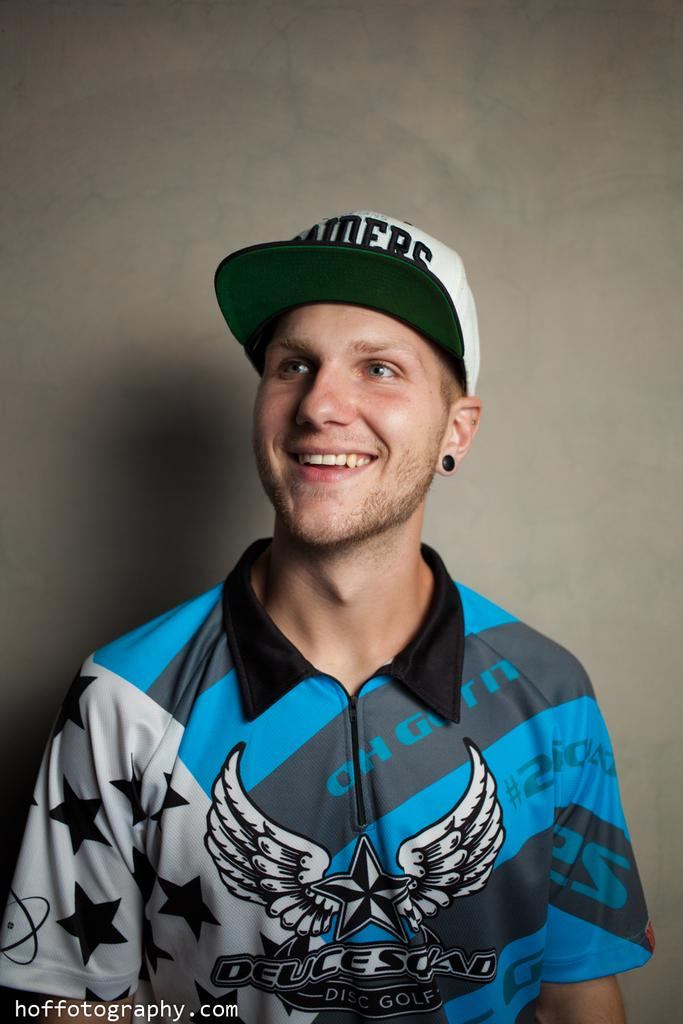Who is present in the image? There is a person in the image. What is the person wearing? The person is wearing a blue and black t-shirt. What expression does the person have? The person is smiling. What can be seen in the background of the image? There is a wall in the background of the image. What is the nature of the text in the image? The text in the image is edited. What type of chain is the person holding in the image? There is no chain present in the image. What subject is the person teaching in the image? There is no indication that the person is teaching in the image. 